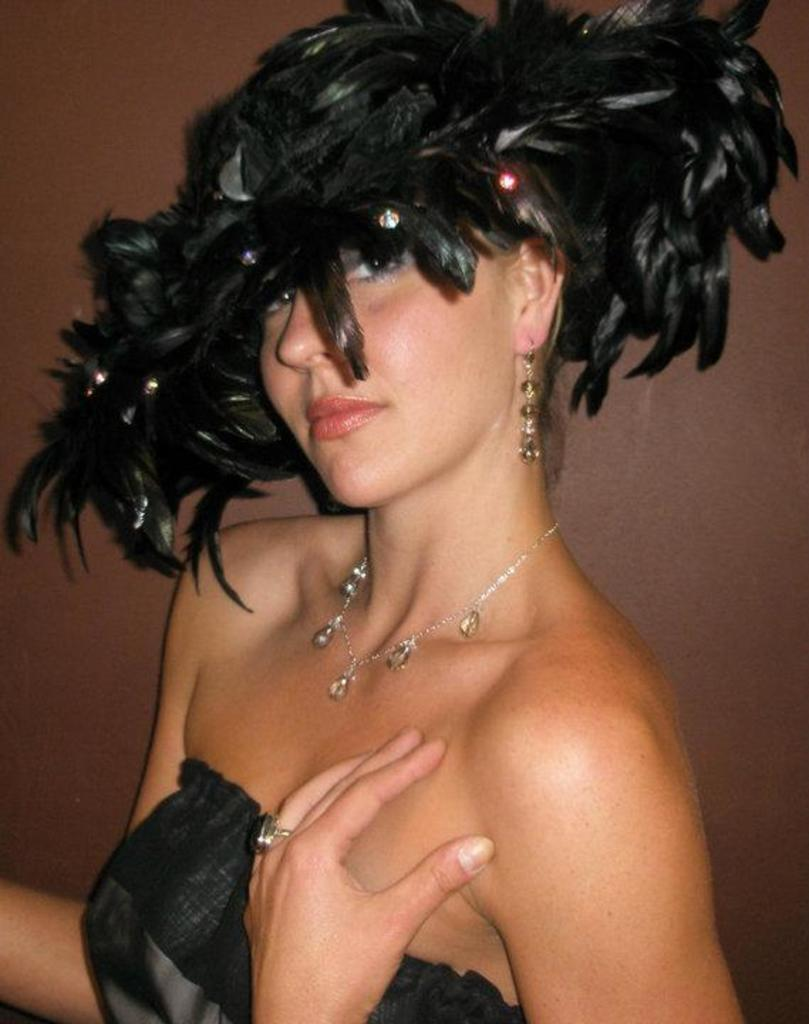Who is the main subject in the image? There is a lady in the center of the image. What is the lady wearing? The lady is wearing a black dress, a chain, and a feather crown. What can be seen in the background of the image? There is a wall in the background of the image. Where are the chickens located in the image? There are no chickens present in the image. What type of apple is being used as a prop in the image? There is no apple present in the image. 